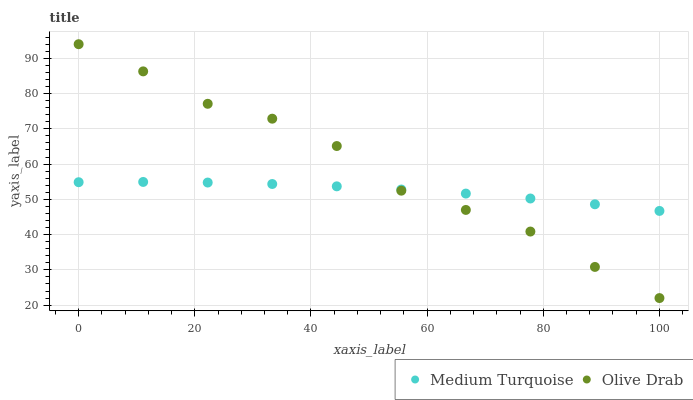Does Medium Turquoise have the minimum area under the curve?
Answer yes or no. Yes. Does Olive Drab have the maximum area under the curve?
Answer yes or no. Yes. Does Medium Turquoise have the maximum area under the curve?
Answer yes or no. No. Is Medium Turquoise the smoothest?
Answer yes or no. Yes. Is Olive Drab the roughest?
Answer yes or no. Yes. Is Medium Turquoise the roughest?
Answer yes or no. No. Does Olive Drab have the lowest value?
Answer yes or no. Yes. Does Medium Turquoise have the lowest value?
Answer yes or no. No. Does Olive Drab have the highest value?
Answer yes or no. Yes. Does Medium Turquoise have the highest value?
Answer yes or no. No. Does Medium Turquoise intersect Olive Drab?
Answer yes or no. Yes. Is Medium Turquoise less than Olive Drab?
Answer yes or no. No. Is Medium Turquoise greater than Olive Drab?
Answer yes or no. No. 